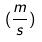<formula> <loc_0><loc_0><loc_500><loc_500>( \frac { m } { s } )</formula> 